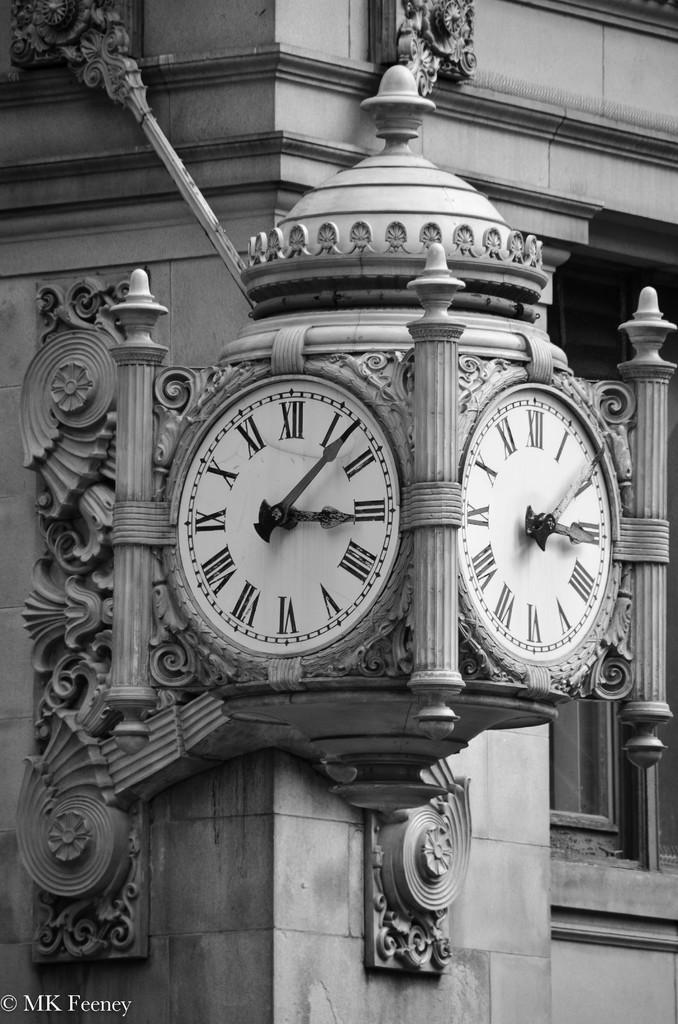<image>
Offer a succinct explanation of the picture presented. A large outdoor clock shows a time of about 3:07. 